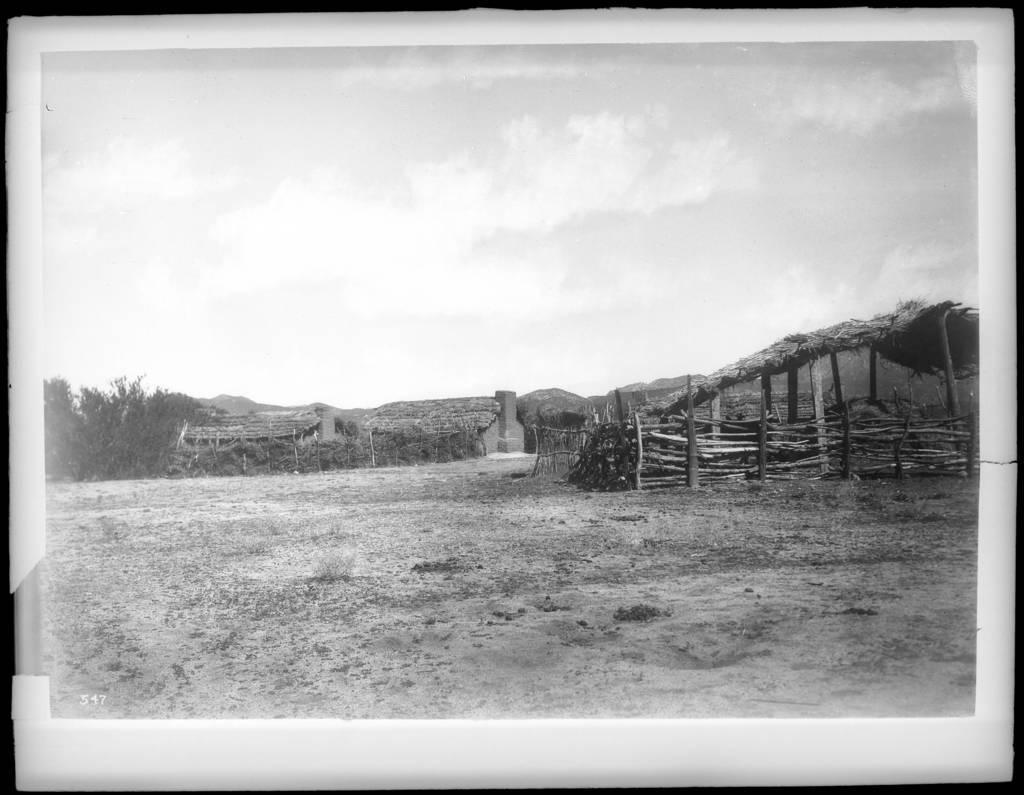Describe this image in one or two sentences. As we can see in the image there is fence, huts, trees and sky. 